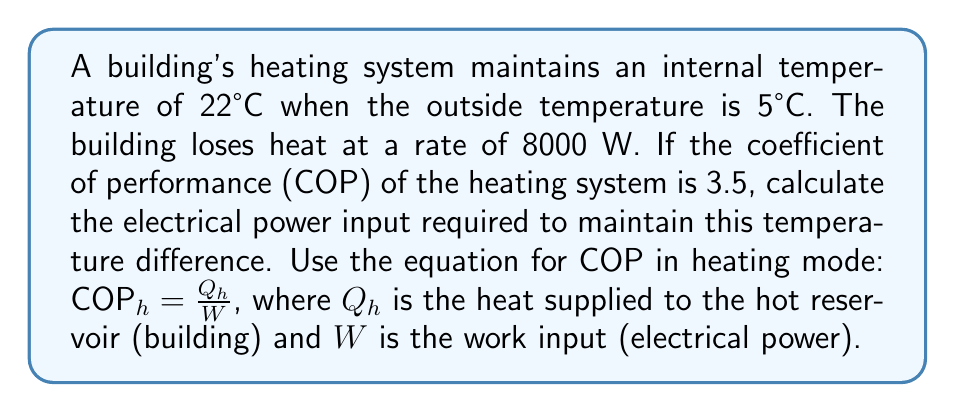Can you answer this question? To solve this problem, we'll follow these steps:

1) First, recall the equation for COP in heating mode:

   $COP_h = \frac{Q_h}{W}$

   Where:
   $COP_h$ is the coefficient of performance for heating
   $Q_h$ is the heat supplied to the hot reservoir (building) in watts
   $W$ is the work input (electrical power) in watts

2) We're given that $COP_h = 3.5$ and we need to find $W$.

3) The heat supplied to the building ($Q_h$) is equal to the heat lost by the building, which is given as 8000 W.

4) Let's substitute these values into our equation:

   $3.5 = \frac{8000}{W}$

5) To solve for $W$, we multiply both sides by $W$:

   $3.5W = 8000$

6) Then divide both sides by 3.5:

   $W = \frac{8000}{3.5}$

7) Calculate the result:

   $W = 2285.71$ W

Therefore, the electrical power input required is approximately 2285.71 watts.
Answer: 2285.71 W 